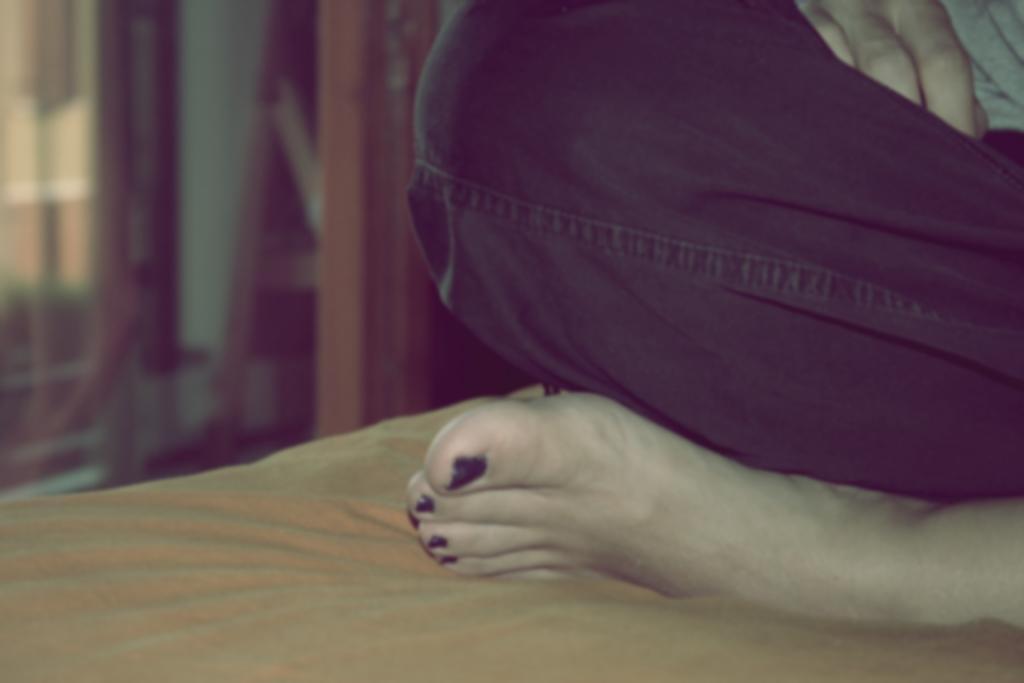In one or two sentences, can you explain what this image depicts? On the right side, there is a person in a pant, sitting on an object, which is covered with a cloth. And the background is blurred. 